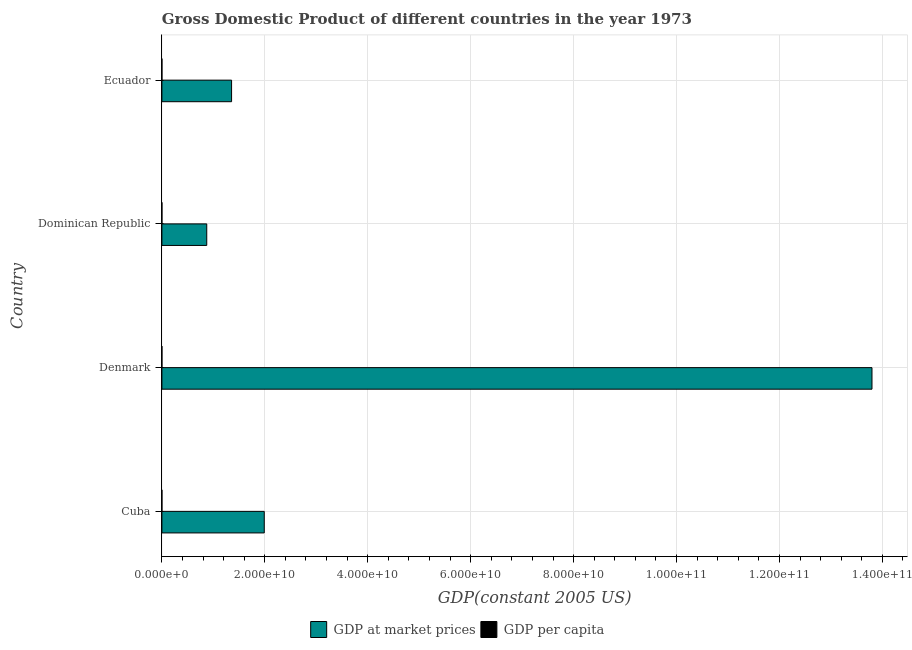How many groups of bars are there?
Offer a terse response. 4. Are the number of bars per tick equal to the number of legend labels?
Ensure brevity in your answer.  Yes. Are the number of bars on each tick of the Y-axis equal?
Your answer should be compact. Yes. How many bars are there on the 3rd tick from the top?
Provide a short and direct response. 2. How many bars are there on the 4th tick from the bottom?
Your answer should be very brief. 2. What is the label of the 4th group of bars from the top?
Keep it short and to the point. Cuba. In how many cases, is the number of bars for a given country not equal to the number of legend labels?
Give a very brief answer. 0. What is the gdp per capita in Cuba?
Make the answer very short. 2167.39. Across all countries, what is the maximum gdp per capita?
Provide a short and direct response. 2.75e+04. Across all countries, what is the minimum gdp per capita?
Provide a succinct answer. 1782.47. In which country was the gdp at market prices maximum?
Offer a terse response. Denmark. In which country was the gdp per capita minimum?
Provide a short and direct response. Dominican Republic. What is the total gdp at market prices in the graph?
Your response must be concise. 1.80e+11. What is the difference between the gdp per capita in Cuba and that in Dominican Republic?
Offer a terse response. 384.91. What is the difference between the gdp at market prices in Dominican Republic and the gdp per capita in Cuba?
Make the answer very short. 8.72e+09. What is the average gdp at market prices per country?
Your answer should be very brief. 4.50e+1. What is the difference between the gdp per capita and gdp at market prices in Dominican Republic?
Your answer should be very brief. -8.72e+09. What is the ratio of the gdp at market prices in Dominican Republic to that in Ecuador?
Offer a terse response. 0.64. Is the gdp at market prices in Denmark less than that in Dominican Republic?
Your response must be concise. No. Is the difference between the gdp per capita in Dominican Republic and Ecuador greater than the difference between the gdp at market prices in Dominican Republic and Ecuador?
Provide a succinct answer. Yes. What is the difference between the highest and the second highest gdp at market prices?
Your response must be concise. 1.18e+11. What is the difference between the highest and the lowest gdp at market prices?
Your answer should be very brief. 1.29e+11. In how many countries, is the gdp per capita greater than the average gdp per capita taken over all countries?
Make the answer very short. 1. Is the sum of the gdp per capita in Cuba and Ecuador greater than the maximum gdp at market prices across all countries?
Provide a short and direct response. No. What does the 1st bar from the top in Denmark represents?
Your answer should be compact. GDP per capita. What does the 1st bar from the bottom in Denmark represents?
Your answer should be compact. GDP at market prices. Are all the bars in the graph horizontal?
Your answer should be very brief. Yes. How many countries are there in the graph?
Give a very brief answer. 4. Are the values on the major ticks of X-axis written in scientific E-notation?
Give a very brief answer. Yes. Does the graph contain any zero values?
Provide a short and direct response. No. Does the graph contain grids?
Give a very brief answer. Yes. How many legend labels are there?
Make the answer very short. 2. What is the title of the graph?
Provide a short and direct response. Gross Domestic Product of different countries in the year 1973. Does "Foreign liabilities" appear as one of the legend labels in the graph?
Make the answer very short. No. What is the label or title of the X-axis?
Give a very brief answer. GDP(constant 2005 US). What is the GDP(constant 2005 US) in GDP at market prices in Cuba?
Make the answer very short. 1.99e+1. What is the GDP(constant 2005 US) in GDP per capita in Cuba?
Your response must be concise. 2167.39. What is the GDP(constant 2005 US) in GDP at market prices in Denmark?
Offer a very short reply. 1.38e+11. What is the GDP(constant 2005 US) of GDP per capita in Denmark?
Offer a very short reply. 2.75e+04. What is the GDP(constant 2005 US) in GDP at market prices in Dominican Republic?
Offer a very short reply. 8.72e+09. What is the GDP(constant 2005 US) of GDP per capita in Dominican Republic?
Your response must be concise. 1782.47. What is the GDP(constant 2005 US) in GDP at market prices in Ecuador?
Offer a terse response. 1.35e+1. What is the GDP(constant 2005 US) in GDP per capita in Ecuador?
Offer a very short reply. 2047.79. Across all countries, what is the maximum GDP(constant 2005 US) of GDP at market prices?
Offer a very short reply. 1.38e+11. Across all countries, what is the maximum GDP(constant 2005 US) of GDP per capita?
Make the answer very short. 2.75e+04. Across all countries, what is the minimum GDP(constant 2005 US) in GDP at market prices?
Keep it short and to the point. 8.72e+09. Across all countries, what is the minimum GDP(constant 2005 US) in GDP per capita?
Provide a succinct answer. 1782.47. What is the total GDP(constant 2005 US) of GDP at market prices in the graph?
Ensure brevity in your answer.  1.80e+11. What is the total GDP(constant 2005 US) of GDP per capita in the graph?
Keep it short and to the point. 3.35e+04. What is the difference between the GDP(constant 2005 US) in GDP at market prices in Cuba and that in Denmark?
Ensure brevity in your answer.  -1.18e+11. What is the difference between the GDP(constant 2005 US) in GDP per capita in Cuba and that in Denmark?
Offer a terse response. -2.53e+04. What is the difference between the GDP(constant 2005 US) in GDP at market prices in Cuba and that in Dominican Republic?
Your answer should be compact. 1.12e+1. What is the difference between the GDP(constant 2005 US) in GDP per capita in Cuba and that in Dominican Republic?
Your answer should be very brief. 384.91. What is the difference between the GDP(constant 2005 US) of GDP at market prices in Cuba and that in Ecuador?
Your answer should be compact. 6.35e+09. What is the difference between the GDP(constant 2005 US) in GDP per capita in Cuba and that in Ecuador?
Your answer should be compact. 119.6. What is the difference between the GDP(constant 2005 US) of GDP at market prices in Denmark and that in Dominican Republic?
Make the answer very short. 1.29e+11. What is the difference between the GDP(constant 2005 US) in GDP per capita in Denmark and that in Dominican Republic?
Provide a short and direct response. 2.57e+04. What is the difference between the GDP(constant 2005 US) of GDP at market prices in Denmark and that in Ecuador?
Offer a terse response. 1.24e+11. What is the difference between the GDP(constant 2005 US) in GDP per capita in Denmark and that in Ecuador?
Keep it short and to the point. 2.54e+04. What is the difference between the GDP(constant 2005 US) of GDP at market prices in Dominican Republic and that in Ecuador?
Provide a succinct answer. -4.82e+09. What is the difference between the GDP(constant 2005 US) in GDP per capita in Dominican Republic and that in Ecuador?
Give a very brief answer. -265.31. What is the difference between the GDP(constant 2005 US) in GDP at market prices in Cuba and the GDP(constant 2005 US) in GDP per capita in Denmark?
Keep it short and to the point. 1.99e+1. What is the difference between the GDP(constant 2005 US) of GDP at market prices in Cuba and the GDP(constant 2005 US) of GDP per capita in Dominican Republic?
Keep it short and to the point. 1.99e+1. What is the difference between the GDP(constant 2005 US) of GDP at market prices in Cuba and the GDP(constant 2005 US) of GDP per capita in Ecuador?
Keep it short and to the point. 1.99e+1. What is the difference between the GDP(constant 2005 US) in GDP at market prices in Denmark and the GDP(constant 2005 US) in GDP per capita in Dominican Republic?
Offer a terse response. 1.38e+11. What is the difference between the GDP(constant 2005 US) in GDP at market prices in Denmark and the GDP(constant 2005 US) in GDP per capita in Ecuador?
Give a very brief answer. 1.38e+11. What is the difference between the GDP(constant 2005 US) of GDP at market prices in Dominican Republic and the GDP(constant 2005 US) of GDP per capita in Ecuador?
Your answer should be compact. 8.72e+09. What is the average GDP(constant 2005 US) of GDP at market prices per country?
Provide a short and direct response. 4.50e+1. What is the average GDP(constant 2005 US) of GDP per capita per country?
Your answer should be compact. 8368.63. What is the difference between the GDP(constant 2005 US) of GDP at market prices and GDP(constant 2005 US) of GDP per capita in Cuba?
Your answer should be very brief. 1.99e+1. What is the difference between the GDP(constant 2005 US) in GDP at market prices and GDP(constant 2005 US) in GDP per capita in Denmark?
Offer a terse response. 1.38e+11. What is the difference between the GDP(constant 2005 US) of GDP at market prices and GDP(constant 2005 US) of GDP per capita in Dominican Republic?
Keep it short and to the point. 8.72e+09. What is the difference between the GDP(constant 2005 US) of GDP at market prices and GDP(constant 2005 US) of GDP per capita in Ecuador?
Your response must be concise. 1.35e+1. What is the ratio of the GDP(constant 2005 US) of GDP at market prices in Cuba to that in Denmark?
Offer a very short reply. 0.14. What is the ratio of the GDP(constant 2005 US) of GDP per capita in Cuba to that in Denmark?
Keep it short and to the point. 0.08. What is the ratio of the GDP(constant 2005 US) in GDP at market prices in Cuba to that in Dominican Republic?
Provide a short and direct response. 2.28. What is the ratio of the GDP(constant 2005 US) in GDP per capita in Cuba to that in Dominican Republic?
Your response must be concise. 1.22. What is the ratio of the GDP(constant 2005 US) in GDP at market prices in Cuba to that in Ecuador?
Your answer should be very brief. 1.47. What is the ratio of the GDP(constant 2005 US) in GDP per capita in Cuba to that in Ecuador?
Your answer should be very brief. 1.06. What is the ratio of the GDP(constant 2005 US) in GDP at market prices in Denmark to that in Dominican Republic?
Make the answer very short. 15.83. What is the ratio of the GDP(constant 2005 US) in GDP per capita in Denmark to that in Dominican Republic?
Keep it short and to the point. 15.41. What is the ratio of the GDP(constant 2005 US) in GDP at market prices in Denmark to that in Ecuador?
Your answer should be compact. 10.19. What is the ratio of the GDP(constant 2005 US) in GDP per capita in Denmark to that in Ecuador?
Offer a terse response. 13.42. What is the ratio of the GDP(constant 2005 US) of GDP at market prices in Dominican Republic to that in Ecuador?
Provide a short and direct response. 0.64. What is the ratio of the GDP(constant 2005 US) in GDP per capita in Dominican Republic to that in Ecuador?
Your answer should be very brief. 0.87. What is the difference between the highest and the second highest GDP(constant 2005 US) of GDP at market prices?
Provide a succinct answer. 1.18e+11. What is the difference between the highest and the second highest GDP(constant 2005 US) of GDP per capita?
Ensure brevity in your answer.  2.53e+04. What is the difference between the highest and the lowest GDP(constant 2005 US) in GDP at market prices?
Provide a short and direct response. 1.29e+11. What is the difference between the highest and the lowest GDP(constant 2005 US) of GDP per capita?
Offer a very short reply. 2.57e+04. 